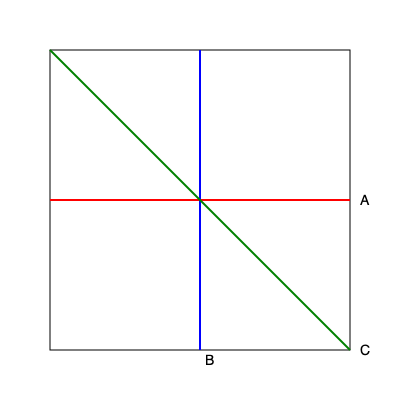In the context of spatial reasoning and its potential impact on moral development, consider a cube being cut by three different planes as shown in the diagram. Which plane would result in a cross-section that could be used to illustrate the concept of "balanced perspectives" in moral decision-making? To answer this question, we need to analyze each plane and its resulting cross-section:

1. Plane A (red): This horizontal plane cuts the cube parallel to its base. The resulting cross-section would be a square, representing a single, uniform perspective.

2. Plane B (blue): This vertical plane cuts the cube parallel to its side. The resulting cross-section would also be a square, again representing a single, uniform perspective.

3. Plane C (green): This diagonal plane cuts the cube from one corner to the opposite corner. The resulting cross-section would be a regular hexagon.

The concept of "balanced perspectives" in moral decision-making implies considering multiple viewpoints or aspects of a situation. Among the given options, the hexagonal cross-section resulting from Plane C best represents this idea:

- The hexagon has six equal sides, which could symbolize different but equally important aspects of a moral dilemma.
- Its symmetry suggests a balanced approach to considering various perspectives.
- The transition from a cubic (three-dimensional) form to a hexagonal (two-dimensional) cross-section could represent the process of simplifying complex moral issues into manageable components.

This analogy aligns with theories in developmental psychology that emphasize the importance of considering multiple perspectives in advanced stages of moral reasoning, such as Kohlberg's post-conventional level or Gilligan's ethic of care.
Answer: Plane C (diagonal) 